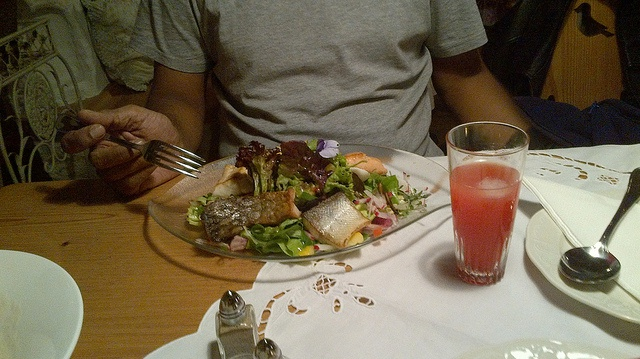Describe the objects in this image and their specific colors. I can see dining table in black, olive, and lightgray tones, people in black, gray, and maroon tones, people in black, darkgreen, and gray tones, chair in black, darkgreen, and gray tones, and cup in black, brown, and maroon tones in this image. 